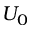<formula> <loc_0><loc_0><loc_500><loc_500>U _ { 0 }</formula> 